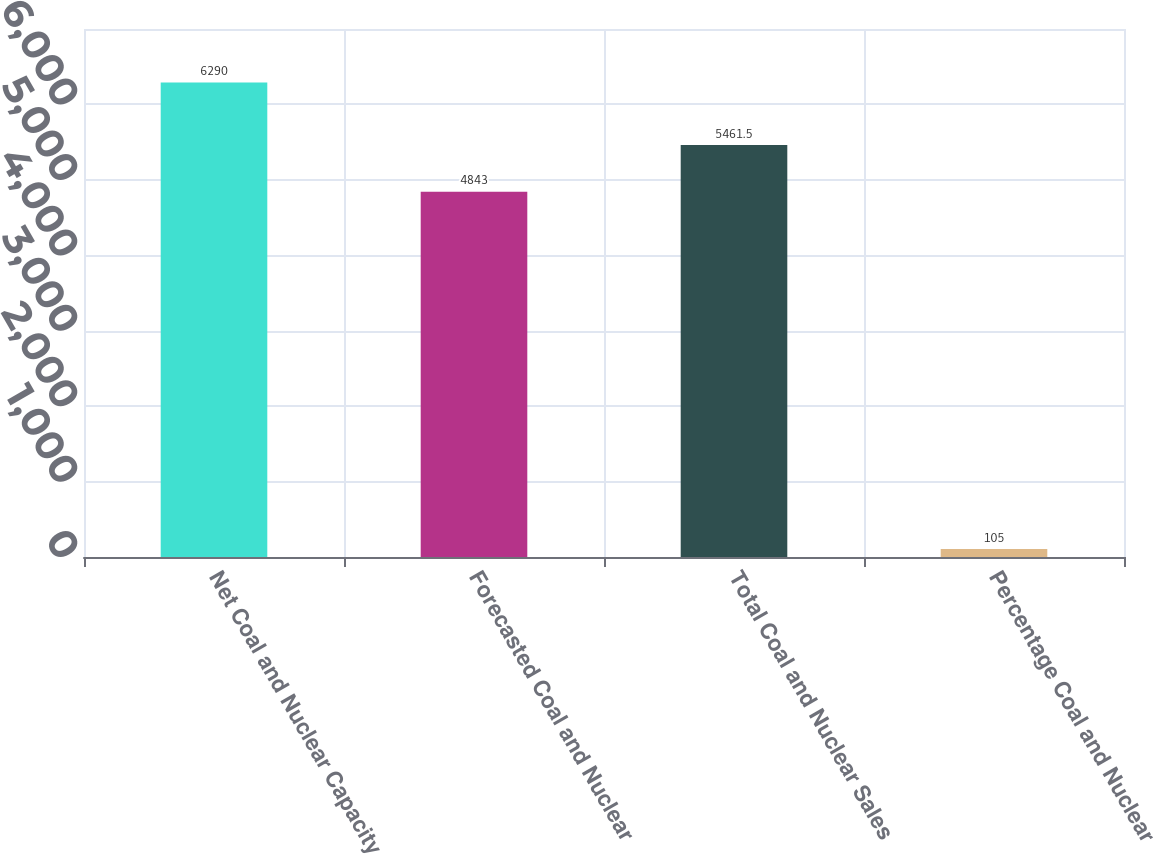Convert chart to OTSL. <chart><loc_0><loc_0><loc_500><loc_500><bar_chart><fcel>Net Coal and Nuclear Capacity<fcel>Forecasted Coal and Nuclear<fcel>Total Coal and Nuclear Sales<fcel>Percentage Coal and Nuclear<nl><fcel>6290<fcel>4843<fcel>5461.5<fcel>105<nl></chart> 